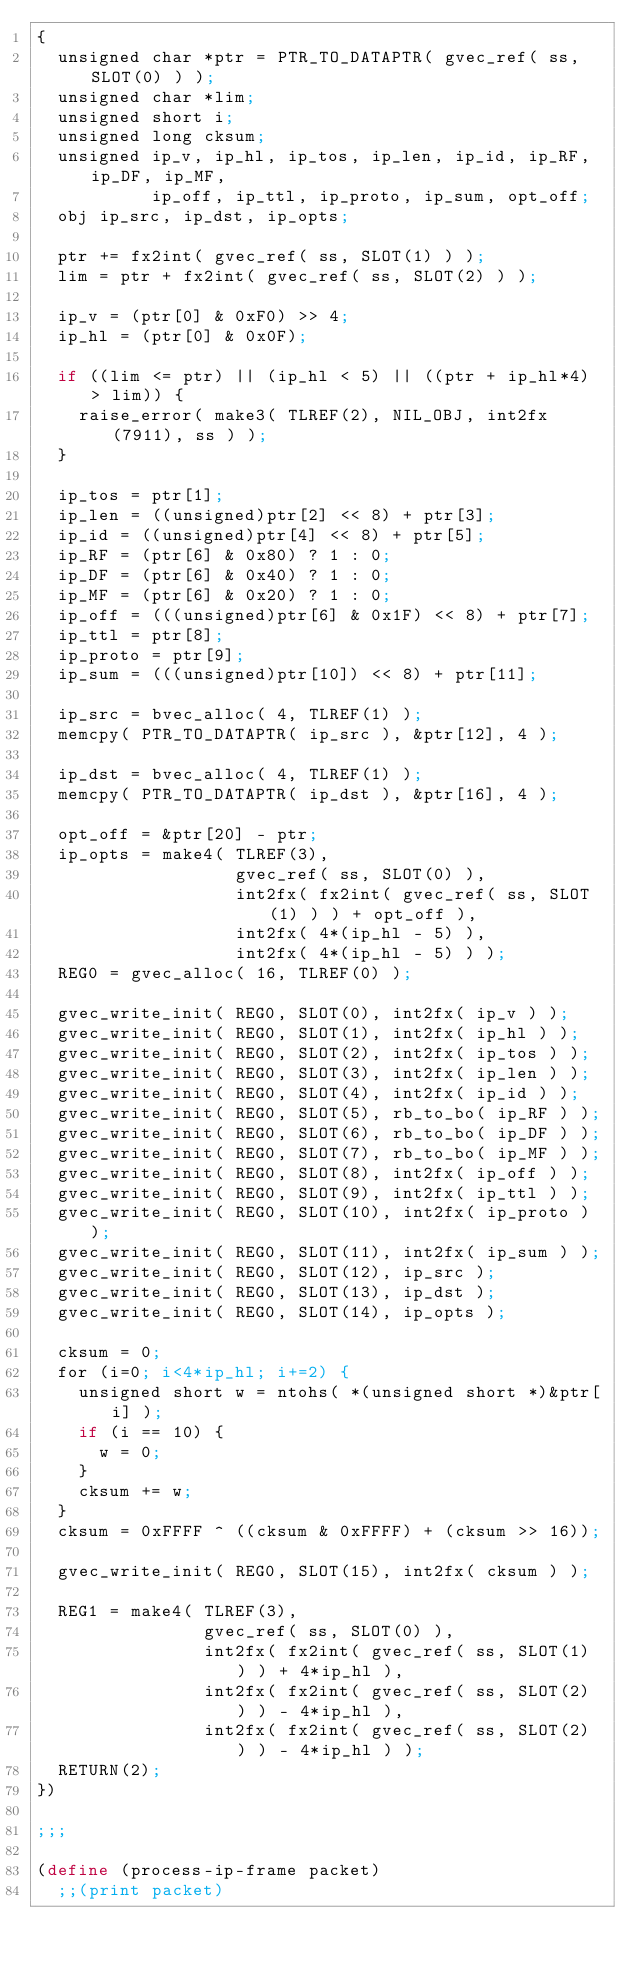Convert code to text. <code><loc_0><loc_0><loc_500><loc_500><_Scheme_>{
  unsigned char *ptr = PTR_TO_DATAPTR( gvec_ref( ss, SLOT(0) ) );
  unsigned char *lim;
  unsigned short i;
  unsigned long cksum;
  unsigned ip_v, ip_hl, ip_tos, ip_len, ip_id, ip_RF, ip_DF, ip_MF,
           ip_off, ip_ttl, ip_proto, ip_sum, opt_off;
  obj ip_src, ip_dst, ip_opts;

  ptr += fx2int( gvec_ref( ss, SLOT(1) ) );
  lim = ptr + fx2int( gvec_ref( ss, SLOT(2) ) );

  ip_v = (ptr[0] & 0xF0) >> 4;
  ip_hl = (ptr[0] & 0x0F);

  if ((lim <= ptr) || (ip_hl < 5) || ((ptr + ip_hl*4) > lim)) {
    raise_error( make3( TLREF(2), NIL_OBJ, int2fx(7911), ss ) );
  }

  ip_tos = ptr[1];
  ip_len = ((unsigned)ptr[2] << 8) + ptr[3];
  ip_id = ((unsigned)ptr[4] << 8) + ptr[5];
  ip_RF = (ptr[6] & 0x80) ? 1 : 0;
  ip_DF = (ptr[6] & 0x40) ? 1 : 0;
  ip_MF = (ptr[6] & 0x20) ? 1 : 0;
  ip_off = (((unsigned)ptr[6] & 0x1F) << 8) + ptr[7];
  ip_ttl = ptr[8];
  ip_proto = ptr[9];
  ip_sum = (((unsigned)ptr[10]) << 8) + ptr[11];

  ip_src = bvec_alloc( 4, TLREF(1) );
  memcpy( PTR_TO_DATAPTR( ip_src ), &ptr[12], 4 );

  ip_dst = bvec_alloc( 4, TLREF(1) );
  memcpy( PTR_TO_DATAPTR( ip_dst ), &ptr[16], 4 );

  opt_off = &ptr[20] - ptr;
  ip_opts = make4( TLREF(3),
                   gvec_ref( ss, SLOT(0) ),
                   int2fx( fx2int( gvec_ref( ss, SLOT(1) ) ) + opt_off ),
                   int2fx( 4*(ip_hl - 5) ),
                   int2fx( 4*(ip_hl - 5) ) );
  REG0 = gvec_alloc( 16, TLREF(0) );

  gvec_write_init( REG0, SLOT(0), int2fx( ip_v ) );
  gvec_write_init( REG0, SLOT(1), int2fx( ip_hl ) );
  gvec_write_init( REG0, SLOT(2), int2fx( ip_tos ) );
  gvec_write_init( REG0, SLOT(3), int2fx( ip_len ) );
  gvec_write_init( REG0, SLOT(4), int2fx( ip_id ) );
  gvec_write_init( REG0, SLOT(5), rb_to_bo( ip_RF ) );
  gvec_write_init( REG0, SLOT(6), rb_to_bo( ip_DF ) );
  gvec_write_init( REG0, SLOT(7), rb_to_bo( ip_MF ) );
  gvec_write_init( REG0, SLOT(8), int2fx( ip_off ) );
  gvec_write_init( REG0, SLOT(9), int2fx( ip_ttl ) );
  gvec_write_init( REG0, SLOT(10), int2fx( ip_proto ) );
  gvec_write_init( REG0, SLOT(11), int2fx( ip_sum ) );
  gvec_write_init( REG0, SLOT(12), ip_src );
  gvec_write_init( REG0, SLOT(13), ip_dst );
  gvec_write_init( REG0, SLOT(14), ip_opts );

  cksum = 0;
  for (i=0; i<4*ip_hl; i+=2) {
    unsigned short w = ntohs( *(unsigned short *)&ptr[i] );
    if (i == 10) {
      w = 0;
    }
    cksum += w;
  }
  cksum = 0xFFFF ^ ((cksum & 0xFFFF) + (cksum >> 16));

  gvec_write_init( REG0, SLOT(15), int2fx( cksum ) );

  REG1 = make4( TLREF(3),
                gvec_ref( ss, SLOT(0) ),
                int2fx( fx2int( gvec_ref( ss, SLOT(1) ) ) + 4*ip_hl ),
                int2fx( fx2int( gvec_ref( ss, SLOT(2) ) ) - 4*ip_hl ),
                int2fx( fx2int( gvec_ref( ss, SLOT(2) ) ) - 4*ip_hl ) );
  RETURN(2);
})

;;;

(define (process-ip-frame packet)
  ;;(print packet)</code> 